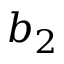Convert formula to latex. <formula><loc_0><loc_0><loc_500><loc_500>b _ { 2 }</formula> 